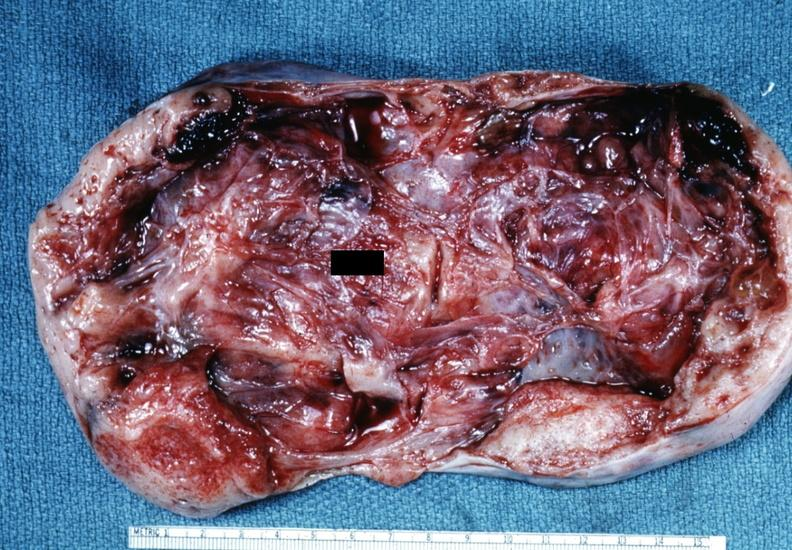s ovary present?
Answer the question using a single word or phrase. Yes 